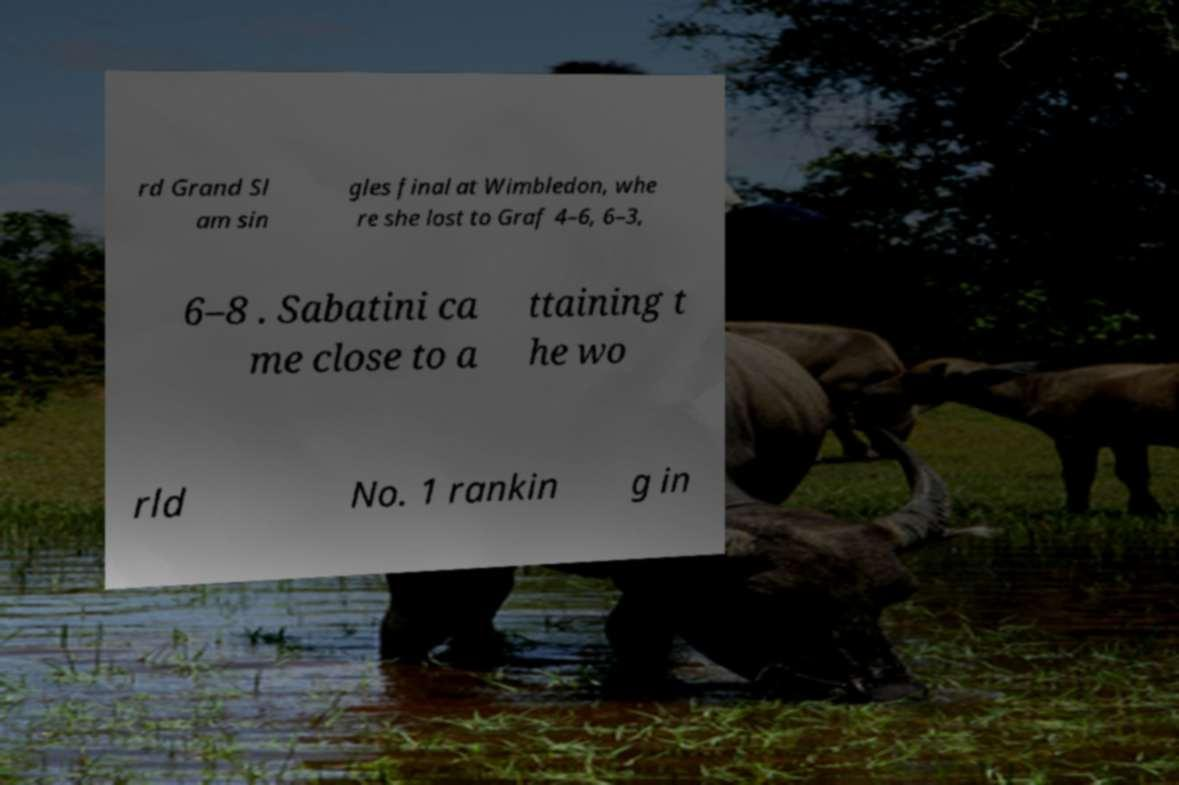Could you assist in decoding the text presented in this image and type it out clearly? rd Grand Sl am sin gles final at Wimbledon, whe re she lost to Graf 4–6, 6–3, 6–8 . Sabatini ca me close to a ttaining t he wo rld No. 1 rankin g in 